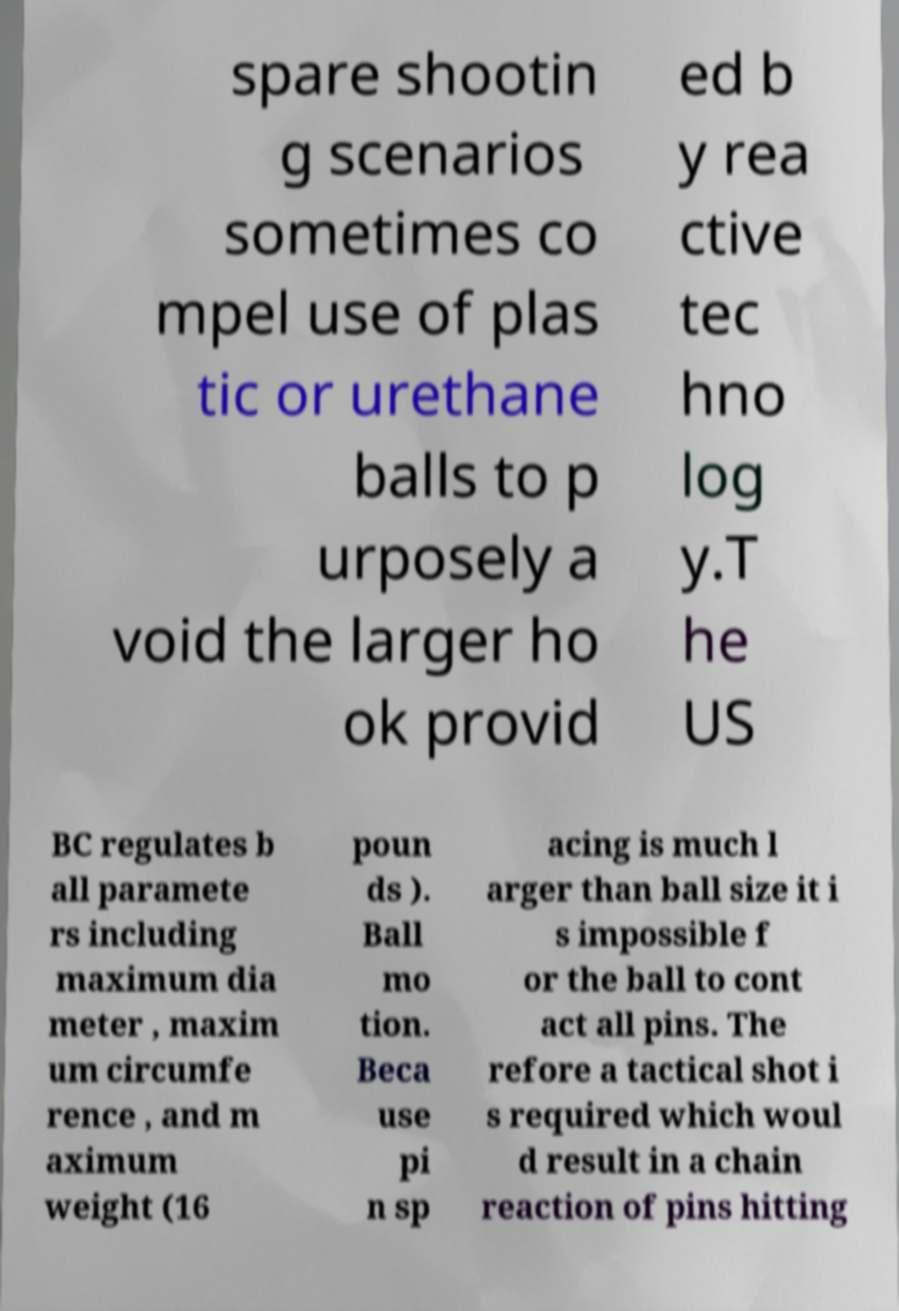For documentation purposes, I need the text within this image transcribed. Could you provide that? spare shootin g scenarios sometimes co mpel use of plas tic or urethane balls to p urposely a void the larger ho ok provid ed b y rea ctive tec hno log y.T he US BC regulates b all paramete rs including maximum dia meter , maxim um circumfe rence , and m aximum weight (16 poun ds ). Ball mo tion. Beca use pi n sp acing is much l arger than ball size it i s impossible f or the ball to cont act all pins. The refore a tactical shot i s required which woul d result in a chain reaction of pins hitting 